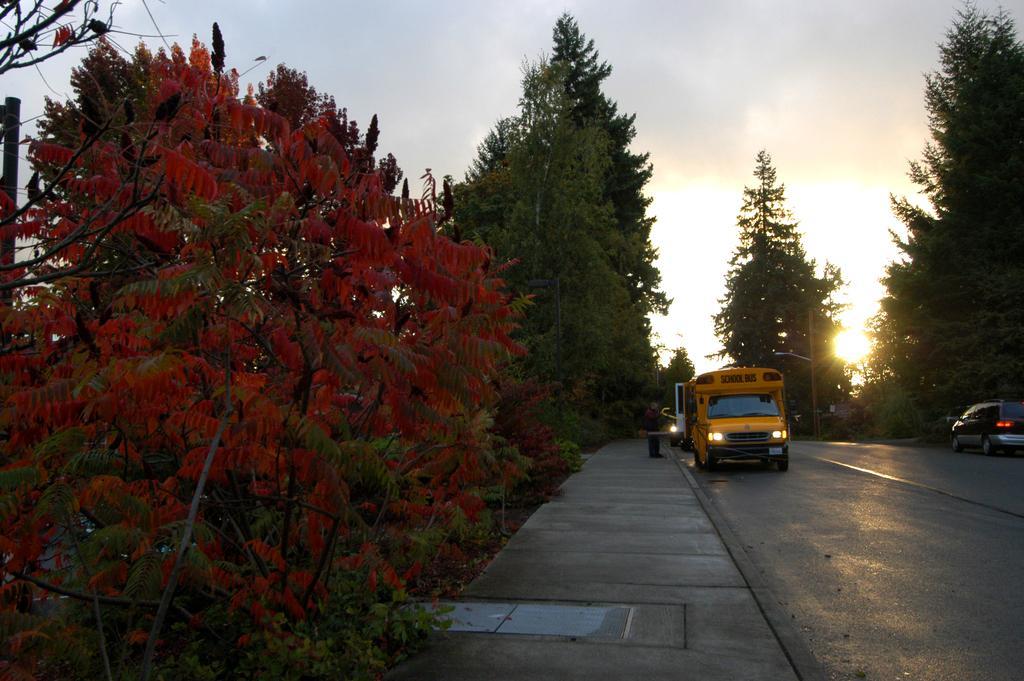Describe this image in one or two sentences. In this picture we can see vehicles on the right side, in the background there are some trees, we can see a person is standing in the middle, there is the sky at the top of the picture. 